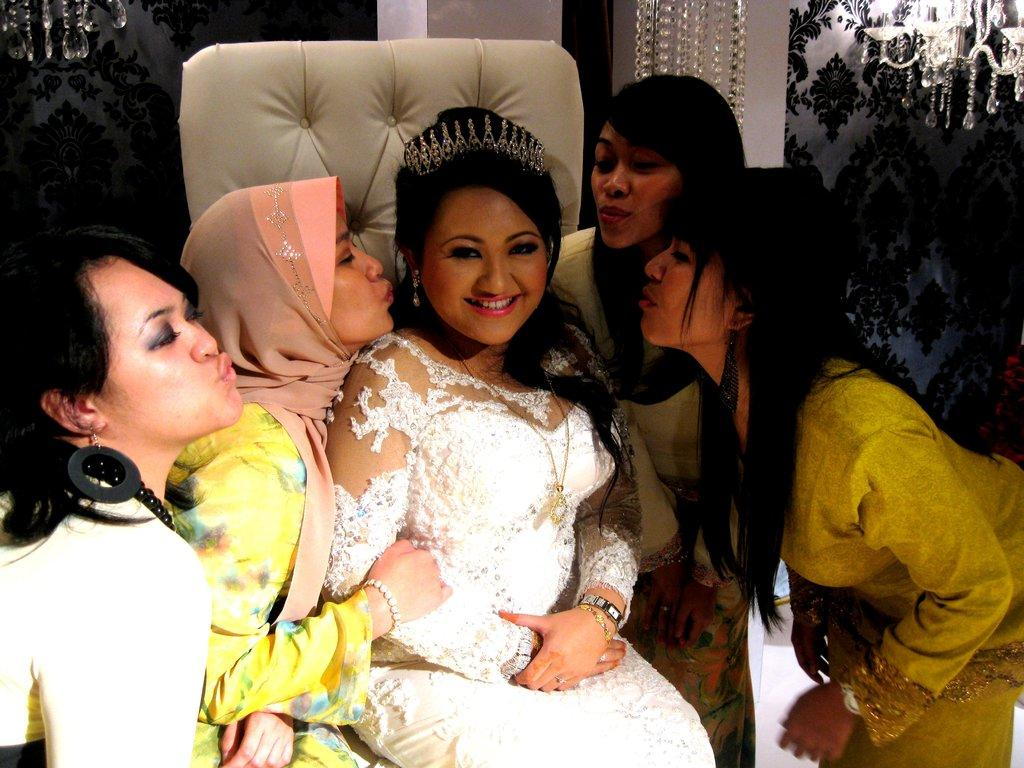Who or what is located in the center of the image? There are women in the center of the image. What type of furniture can be seen in the image? There is a chair in the image. What architectural feature is present in the image? There is a wall in the image. Are there any other structural elements visible in the image? Yes, there are pillars in the image. What type of cheese is being served in the image? There is no cheese present in the image. What direction is the image facing, towards the north or south? The image does not provide any information about its orientation or direction. 